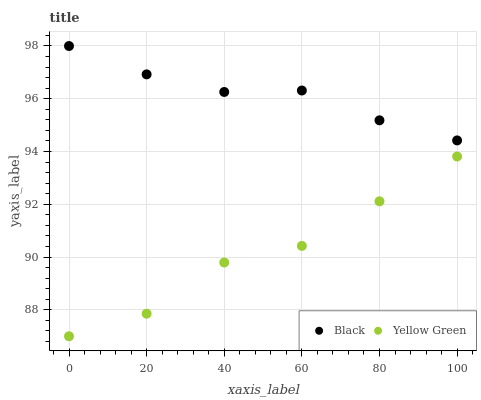Does Yellow Green have the minimum area under the curve?
Answer yes or no. Yes. Does Black have the maximum area under the curve?
Answer yes or no. Yes. Does Yellow Green have the maximum area under the curve?
Answer yes or no. No. Is Black the smoothest?
Answer yes or no. Yes. Is Yellow Green the roughest?
Answer yes or no. Yes. Is Yellow Green the smoothest?
Answer yes or no. No. Does Yellow Green have the lowest value?
Answer yes or no. Yes. Does Black have the highest value?
Answer yes or no. Yes. Does Yellow Green have the highest value?
Answer yes or no. No. Is Yellow Green less than Black?
Answer yes or no. Yes. Is Black greater than Yellow Green?
Answer yes or no. Yes. Does Yellow Green intersect Black?
Answer yes or no. No. 